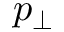<formula> <loc_0><loc_0><loc_500><loc_500>p _ { \perp }</formula> 